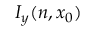<formula> <loc_0><loc_0><loc_500><loc_500>I _ { y } ( n , x _ { 0 } )</formula> 